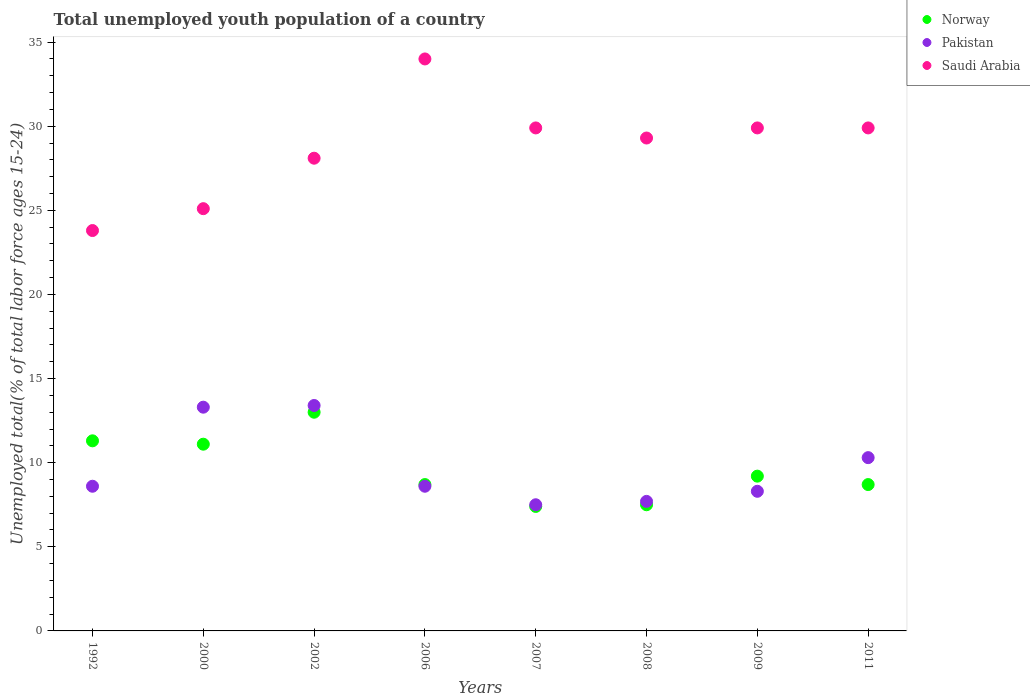How many different coloured dotlines are there?
Your answer should be compact. 3. Is the number of dotlines equal to the number of legend labels?
Your answer should be very brief. Yes. What is the percentage of total unemployed youth population of a country in Pakistan in 2006?
Ensure brevity in your answer.  8.6. Across all years, what is the minimum percentage of total unemployed youth population of a country in Norway?
Offer a terse response. 7.4. In which year was the percentage of total unemployed youth population of a country in Pakistan maximum?
Provide a short and direct response. 2002. In which year was the percentage of total unemployed youth population of a country in Norway minimum?
Your response must be concise. 2007. What is the total percentage of total unemployed youth population of a country in Pakistan in the graph?
Make the answer very short. 77.7. What is the difference between the percentage of total unemployed youth population of a country in Norway in 1992 and that in 2002?
Provide a short and direct response. -1.7. What is the difference between the percentage of total unemployed youth population of a country in Pakistan in 2009 and the percentage of total unemployed youth population of a country in Saudi Arabia in 2008?
Your answer should be compact. -21. What is the average percentage of total unemployed youth population of a country in Saudi Arabia per year?
Give a very brief answer. 28.75. In the year 2007, what is the difference between the percentage of total unemployed youth population of a country in Pakistan and percentage of total unemployed youth population of a country in Norway?
Ensure brevity in your answer.  0.1. What is the ratio of the percentage of total unemployed youth population of a country in Pakistan in 1992 to that in 2000?
Provide a short and direct response. 0.65. What is the difference between the highest and the second highest percentage of total unemployed youth population of a country in Saudi Arabia?
Offer a terse response. 4.1. What is the difference between the highest and the lowest percentage of total unemployed youth population of a country in Norway?
Keep it short and to the point. 5.6. In how many years, is the percentage of total unemployed youth population of a country in Norway greater than the average percentage of total unemployed youth population of a country in Norway taken over all years?
Make the answer very short. 3. Is the sum of the percentage of total unemployed youth population of a country in Norway in 1992 and 2006 greater than the maximum percentage of total unemployed youth population of a country in Saudi Arabia across all years?
Offer a very short reply. No. Is it the case that in every year, the sum of the percentage of total unemployed youth population of a country in Norway and percentage of total unemployed youth population of a country in Pakistan  is greater than the percentage of total unemployed youth population of a country in Saudi Arabia?
Provide a succinct answer. No. Is the percentage of total unemployed youth population of a country in Saudi Arabia strictly greater than the percentage of total unemployed youth population of a country in Pakistan over the years?
Keep it short and to the point. Yes. Is the percentage of total unemployed youth population of a country in Saudi Arabia strictly less than the percentage of total unemployed youth population of a country in Pakistan over the years?
Your response must be concise. No. How many dotlines are there?
Offer a terse response. 3. How many years are there in the graph?
Your response must be concise. 8. Does the graph contain any zero values?
Give a very brief answer. No. How many legend labels are there?
Your answer should be very brief. 3. What is the title of the graph?
Provide a short and direct response. Total unemployed youth population of a country. Does "High income" appear as one of the legend labels in the graph?
Provide a succinct answer. No. What is the label or title of the Y-axis?
Your answer should be compact. Unemployed total(% of total labor force ages 15-24). What is the Unemployed total(% of total labor force ages 15-24) of Norway in 1992?
Offer a very short reply. 11.3. What is the Unemployed total(% of total labor force ages 15-24) of Pakistan in 1992?
Provide a succinct answer. 8.6. What is the Unemployed total(% of total labor force ages 15-24) in Saudi Arabia in 1992?
Provide a succinct answer. 23.8. What is the Unemployed total(% of total labor force ages 15-24) of Norway in 2000?
Your answer should be very brief. 11.1. What is the Unemployed total(% of total labor force ages 15-24) of Pakistan in 2000?
Provide a short and direct response. 13.3. What is the Unemployed total(% of total labor force ages 15-24) of Saudi Arabia in 2000?
Your answer should be very brief. 25.1. What is the Unemployed total(% of total labor force ages 15-24) of Pakistan in 2002?
Your answer should be very brief. 13.4. What is the Unemployed total(% of total labor force ages 15-24) of Saudi Arabia in 2002?
Give a very brief answer. 28.1. What is the Unemployed total(% of total labor force ages 15-24) of Norway in 2006?
Provide a short and direct response. 8.7. What is the Unemployed total(% of total labor force ages 15-24) in Pakistan in 2006?
Your answer should be very brief. 8.6. What is the Unemployed total(% of total labor force ages 15-24) of Norway in 2007?
Provide a succinct answer. 7.4. What is the Unemployed total(% of total labor force ages 15-24) in Saudi Arabia in 2007?
Make the answer very short. 29.9. What is the Unemployed total(% of total labor force ages 15-24) of Pakistan in 2008?
Your answer should be compact. 7.7. What is the Unemployed total(% of total labor force ages 15-24) in Saudi Arabia in 2008?
Your answer should be compact. 29.3. What is the Unemployed total(% of total labor force ages 15-24) of Norway in 2009?
Offer a terse response. 9.2. What is the Unemployed total(% of total labor force ages 15-24) of Pakistan in 2009?
Ensure brevity in your answer.  8.3. What is the Unemployed total(% of total labor force ages 15-24) of Saudi Arabia in 2009?
Give a very brief answer. 29.9. What is the Unemployed total(% of total labor force ages 15-24) of Norway in 2011?
Provide a short and direct response. 8.7. What is the Unemployed total(% of total labor force ages 15-24) in Pakistan in 2011?
Provide a short and direct response. 10.3. What is the Unemployed total(% of total labor force ages 15-24) in Saudi Arabia in 2011?
Keep it short and to the point. 29.9. Across all years, what is the maximum Unemployed total(% of total labor force ages 15-24) of Pakistan?
Your response must be concise. 13.4. Across all years, what is the maximum Unemployed total(% of total labor force ages 15-24) in Saudi Arabia?
Provide a succinct answer. 34. Across all years, what is the minimum Unemployed total(% of total labor force ages 15-24) of Norway?
Your answer should be compact. 7.4. Across all years, what is the minimum Unemployed total(% of total labor force ages 15-24) of Pakistan?
Your answer should be very brief. 7.5. Across all years, what is the minimum Unemployed total(% of total labor force ages 15-24) of Saudi Arabia?
Provide a succinct answer. 23.8. What is the total Unemployed total(% of total labor force ages 15-24) of Norway in the graph?
Keep it short and to the point. 76.9. What is the total Unemployed total(% of total labor force ages 15-24) of Pakistan in the graph?
Offer a very short reply. 77.7. What is the total Unemployed total(% of total labor force ages 15-24) in Saudi Arabia in the graph?
Provide a succinct answer. 230. What is the difference between the Unemployed total(% of total labor force ages 15-24) in Pakistan in 1992 and that in 2002?
Your answer should be compact. -4.8. What is the difference between the Unemployed total(% of total labor force ages 15-24) in Saudi Arabia in 1992 and that in 2002?
Offer a very short reply. -4.3. What is the difference between the Unemployed total(% of total labor force ages 15-24) of Norway in 1992 and that in 2006?
Keep it short and to the point. 2.6. What is the difference between the Unemployed total(% of total labor force ages 15-24) of Saudi Arabia in 1992 and that in 2006?
Provide a short and direct response. -10.2. What is the difference between the Unemployed total(% of total labor force ages 15-24) of Norway in 1992 and that in 2008?
Make the answer very short. 3.8. What is the difference between the Unemployed total(% of total labor force ages 15-24) in Pakistan in 1992 and that in 2008?
Offer a very short reply. 0.9. What is the difference between the Unemployed total(% of total labor force ages 15-24) of Pakistan in 1992 and that in 2009?
Offer a terse response. 0.3. What is the difference between the Unemployed total(% of total labor force ages 15-24) in Saudi Arabia in 1992 and that in 2009?
Provide a short and direct response. -6.1. What is the difference between the Unemployed total(% of total labor force ages 15-24) of Saudi Arabia in 1992 and that in 2011?
Give a very brief answer. -6.1. What is the difference between the Unemployed total(% of total labor force ages 15-24) of Pakistan in 2000 and that in 2002?
Provide a succinct answer. -0.1. What is the difference between the Unemployed total(% of total labor force ages 15-24) of Pakistan in 2000 and that in 2006?
Ensure brevity in your answer.  4.7. What is the difference between the Unemployed total(% of total labor force ages 15-24) in Saudi Arabia in 2000 and that in 2006?
Offer a terse response. -8.9. What is the difference between the Unemployed total(% of total labor force ages 15-24) in Pakistan in 2000 and that in 2007?
Keep it short and to the point. 5.8. What is the difference between the Unemployed total(% of total labor force ages 15-24) in Norway in 2000 and that in 2008?
Ensure brevity in your answer.  3.6. What is the difference between the Unemployed total(% of total labor force ages 15-24) in Saudi Arabia in 2000 and that in 2008?
Your answer should be very brief. -4.2. What is the difference between the Unemployed total(% of total labor force ages 15-24) in Norway in 2000 and that in 2009?
Offer a terse response. 1.9. What is the difference between the Unemployed total(% of total labor force ages 15-24) in Pakistan in 2000 and that in 2009?
Your answer should be very brief. 5. What is the difference between the Unemployed total(% of total labor force ages 15-24) in Saudi Arabia in 2000 and that in 2009?
Make the answer very short. -4.8. What is the difference between the Unemployed total(% of total labor force ages 15-24) in Norway in 2000 and that in 2011?
Keep it short and to the point. 2.4. What is the difference between the Unemployed total(% of total labor force ages 15-24) of Norway in 2002 and that in 2007?
Your answer should be compact. 5.6. What is the difference between the Unemployed total(% of total labor force ages 15-24) in Norway in 2002 and that in 2011?
Provide a succinct answer. 4.3. What is the difference between the Unemployed total(% of total labor force ages 15-24) in Saudi Arabia in 2002 and that in 2011?
Give a very brief answer. -1.8. What is the difference between the Unemployed total(% of total labor force ages 15-24) in Norway in 2006 and that in 2007?
Make the answer very short. 1.3. What is the difference between the Unemployed total(% of total labor force ages 15-24) of Norway in 2006 and that in 2008?
Make the answer very short. 1.2. What is the difference between the Unemployed total(% of total labor force ages 15-24) of Saudi Arabia in 2006 and that in 2008?
Ensure brevity in your answer.  4.7. What is the difference between the Unemployed total(% of total labor force ages 15-24) of Norway in 2006 and that in 2009?
Offer a very short reply. -0.5. What is the difference between the Unemployed total(% of total labor force ages 15-24) of Pakistan in 2006 and that in 2009?
Offer a terse response. 0.3. What is the difference between the Unemployed total(% of total labor force ages 15-24) of Saudi Arabia in 2006 and that in 2009?
Offer a very short reply. 4.1. What is the difference between the Unemployed total(% of total labor force ages 15-24) of Norway in 2006 and that in 2011?
Your answer should be compact. 0. What is the difference between the Unemployed total(% of total labor force ages 15-24) of Saudi Arabia in 2006 and that in 2011?
Your answer should be compact. 4.1. What is the difference between the Unemployed total(% of total labor force ages 15-24) of Pakistan in 2007 and that in 2008?
Your answer should be very brief. -0.2. What is the difference between the Unemployed total(% of total labor force ages 15-24) in Saudi Arabia in 2007 and that in 2009?
Offer a very short reply. 0. What is the difference between the Unemployed total(% of total labor force ages 15-24) of Saudi Arabia in 2007 and that in 2011?
Ensure brevity in your answer.  0. What is the difference between the Unemployed total(% of total labor force ages 15-24) in Saudi Arabia in 2008 and that in 2009?
Offer a very short reply. -0.6. What is the difference between the Unemployed total(% of total labor force ages 15-24) of Saudi Arabia in 2008 and that in 2011?
Offer a terse response. -0.6. What is the difference between the Unemployed total(% of total labor force ages 15-24) of Pakistan in 1992 and the Unemployed total(% of total labor force ages 15-24) of Saudi Arabia in 2000?
Provide a succinct answer. -16.5. What is the difference between the Unemployed total(% of total labor force ages 15-24) of Norway in 1992 and the Unemployed total(% of total labor force ages 15-24) of Saudi Arabia in 2002?
Keep it short and to the point. -16.8. What is the difference between the Unemployed total(% of total labor force ages 15-24) of Pakistan in 1992 and the Unemployed total(% of total labor force ages 15-24) of Saudi Arabia in 2002?
Your answer should be compact. -19.5. What is the difference between the Unemployed total(% of total labor force ages 15-24) of Norway in 1992 and the Unemployed total(% of total labor force ages 15-24) of Saudi Arabia in 2006?
Give a very brief answer. -22.7. What is the difference between the Unemployed total(% of total labor force ages 15-24) of Pakistan in 1992 and the Unemployed total(% of total labor force ages 15-24) of Saudi Arabia in 2006?
Your response must be concise. -25.4. What is the difference between the Unemployed total(% of total labor force ages 15-24) in Norway in 1992 and the Unemployed total(% of total labor force ages 15-24) in Pakistan in 2007?
Your answer should be compact. 3.8. What is the difference between the Unemployed total(% of total labor force ages 15-24) of Norway in 1992 and the Unemployed total(% of total labor force ages 15-24) of Saudi Arabia in 2007?
Provide a short and direct response. -18.6. What is the difference between the Unemployed total(% of total labor force ages 15-24) in Pakistan in 1992 and the Unemployed total(% of total labor force ages 15-24) in Saudi Arabia in 2007?
Your response must be concise. -21.3. What is the difference between the Unemployed total(% of total labor force ages 15-24) of Pakistan in 1992 and the Unemployed total(% of total labor force ages 15-24) of Saudi Arabia in 2008?
Your answer should be compact. -20.7. What is the difference between the Unemployed total(% of total labor force ages 15-24) of Norway in 1992 and the Unemployed total(% of total labor force ages 15-24) of Pakistan in 2009?
Your response must be concise. 3. What is the difference between the Unemployed total(% of total labor force ages 15-24) in Norway in 1992 and the Unemployed total(% of total labor force ages 15-24) in Saudi Arabia in 2009?
Provide a succinct answer. -18.6. What is the difference between the Unemployed total(% of total labor force ages 15-24) of Pakistan in 1992 and the Unemployed total(% of total labor force ages 15-24) of Saudi Arabia in 2009?
Your response must be concise. -21.3. What is the difference between the Unemployed total(% of total labor force ages 15-24) of Norway in 1992 and the Unemployed total(% of total labor force ages 15-24) of Pakistan in 2011?
Your response must be concise. 1. What is the difference between the Unemployed total(% of total labor force ages 15-24) of Norway in 1992 and the Unemployed total(% of total labor force ages 15-24) of Saudi Arabia in 2011?
Give a very brief answer. -18.6. What is the difference between the Unemployed total(% of total labor force ages 15-24) in Pakistan in 1992 and the Unemployed total(% of total labor force ages 15-24) in Saudi Arabia in 2011?
Offer a very short reply. -21.3. What is the difference between the Unemployed total(% of total labor force ages 15-24) in Norway in 2000 and the Unemployed total(% of total labor force ages 15-24) in Saudi Arabia in 2002?
Offer a terse response. -17. What is the difference between the Unemployed total(% of total labor force ages 15-24) of Pakistan in 2000 and the Unemployed total(% of total labor force ages 15-24) of Saudi Arabia in 2002?
Provide a succinct answer. -14.8. What is the difference between the Unemployed total(% of total labor force ages 15-24) in Norway in 2000 and the Unemployed total(% of total labor force ages 15-24) in Saudi Arabia in 2006?
Give a very brief answer. -22.9. What is the difference between the Unemployed total(% of total labor force ages 15-24) of Pakistan in 2000 and the Unemployed total(% of total labor force ages 15-24) of Saudi Arabia in 2006?
Ensure brevity in your answer.  -20.7. What is the difference between the Unemployed total(% of total labor force ages 15-24) in Norway in 2000 and the Unemployed total(% of total labor force ages 15-24) in Saudi Arabia in 2007?
Ensure brevity in your answer.  -18.8. What is the difference between the Unemployed total(% of total labor force ages 15-24) in Pakistan in 2000 and the Unemployed total(% of total labor force ages 15-24) in Saudi Arabia in 2007?
Offer a very short reply. -16.6. What is the difference between the Unemployed total(% of total labor force ages 15-24) in Norway in 2000 and the Unemployed total(% of total labor force ages 15-24) in Saudi Arabia in 2008?
Give a very brief answer. -18.2. What is the difference between the Unemployed total(% of total labor force ages 15-24) of Pakistan in 2000 and the Unemployed total(% of total labor force ages 15-24) of Saudi Arabia in 2008?
Ensure brevity in your answer.  -16. What is the difference between the Unemployed total(% of total labor force ages 15-24) of Norway in 2000 and the Unemployed total(% of total labor force ages 15-24) of Pakistan in 2009?
Make the answer very short. 2.8. What is the difference between the Unemployed total(% of total labor force ages 15-24) of Norway in 2000 and the Unemployed total(% of total labor force ages 15-24) of Saudi Arabia in 2009?
Ensure brevity in your answer.  -18.8. What is the difference between the Unemployed total(% of total labor force ages 15-24) in Pakistan in 2000 and the Unemployed total(% of total labor force ages 15-24) in Saudi Arabia in 2009?
Provide a short and direct response. -16.6. What is the difference between the Unemployed total(% of total labor force ages 15-24) of Norway in 2000 and the Unemployed total(% of total labor force ages 15-24) of Saudi Arabia in 2011?
Offer a terse response. -18.8. What is the difference between the Unemployed total(% of total labor force ages 15-24) of Pakistan in 2000 and the Unemployed total(% of total labor force ages 15-24) of Saudi Arabia in 2011?
Make the answer very short. -16.6. What is the difference between the Unemployed total(% of total labor force ages 15-24) of Norway in 2002 and the Unemployed total(% of total labor force ages 15-24) of Pakistan in 2006?
Offer a very short reply. 4.4. What is the difference between the Unemployed total(% of total labor force ages 15-24) in Pakistan in 2002 and the Unemployed total(% of total labor force ages 15-24) in Saudi Arabia in 2006?
Your response must be concise. -20.6. What is the difference between the Unemployed total(% of total labor force ages 15-24) in Norway in 2002 and the Unemployed total(% of total labor force ages 15-24) in Saudi Arabia in 2007?
Your response must be concise. -16.9. What is the difference between the Unemployed total(% of total labor force ages 15-24) of Pakistan in 2002 and the Unemployed total(% of total labor force ages 15-24) of Saudi Arabia in 2007?
Provide a short and direct response. -16.5. What is the difference between the Unemployed total(% of total labor force ages 15-24) in Norway in 2002 and the Unemployed total(% of total labor force ages 15-24) in Pakistan in 2008?
Offer a very short reply. 5.3. What is the difference between the Unemployed total(% of total labor force ages 15-24) of Norway in 2002 and the Unemployed total(% of total labor force ages 15-24) of Saudi Arabia in 2008?
Give a very brief answer. -16.3. What is the difference between the Unemployed total(% of total labor force ages 15-24) in Pakistan in 2002 and the Unemployed total(% of total labor force ages 15-24) in Saudi Arabia in 2008?
Provide a succinct answer. -15.9. What is the difference between the Unemployed total(% of total labor force ages 15-24) in Norway in 2002 and the Unemployed total(% of total labor force ages 15-24) in Saudi Arabia in 2009?
Keep it short and to the point. -16.9. What is the difference between the Unemployed total(% of total labor force ages 15-24) of Pakistan in 2002 and the Unemployed total(% of total labor force ages 15-24) of Saudi Arabia in 2009?
Make the answer very short. -16.5. What is the difference between the Unemployed total(% of total labor force ages 15-24) in Norway in 2002 and the Unemployed total(% of total labor force ages 15-24) in Pakistan in 2011?
Your response must be concise. 2.7. What is the difference between the Unemployed total(% of total labor force ages 15-24) in Norway in 2002 and the Unemployed total(% of total labor force ages 15-24) in Saudi Arabia in 2011?
Your response must be concise. -16.9. What is the difference between the Unemployed total(% of total labor force ages 15-24) of Pakistan in 2002 and the Unemployed total(% of total labor force ages 15-24) of Saudi Arabia in 2011?
Your answer should be compact. -16.5. What is the difference between the Unemployed total(% of total labor force ages 15-24) in Norway in 2006 and the Unemployed total(% of total labor force ages 15-24) in Pakistan in 2007?
Offer a terse response. 1.2. What is the difference between the Unemployed total(% of total labor force ages 15-24) of Norway in 2006 and the Unemployed total(% of total labor force ages 15-24) of Saudi Arabia in 2007?
Your answer should be very brief. -21.2. What is the difference between the Unemployed total(% of total labor force ages 15-24) in Pakistan in 2006 and the Unemployed total(% of total labor force ages 15-24) in Saudi Arabia in 2007?
Offer a very short reply. -21.3. What is the difference between the Unemployed total(% of total labor force ages 15-24) of Norway in 2006 and the Unemployed total(% of total labor force ages 15-24) of Pakistan in 2008?
Give a very brief answer. 1. What is the difference between the Unemployed total(% of total labor force ages 15-24) in Norway in 2006 and the Unemployed total(% of total labor force ages 15-24) in Saudi Arabia in 2008?
Offer a terse response. -20.6. What is the difference between the Unemployed total(% of total labor force ages 15-24) of Pakistan in 2006 and the Unemployed total(% of total labor force ages 15-24) of Saudi Arabia in 2008?
Your answer should be very brief. -20.7. What is the difference between the Unemployed total(% of total labor force ages 15-24) in Norway in 2006 and the Unemployed total(% of total labor force ages 15-24) in Saudi Arabia in 2009?
Make the answer very short. -21.2. What is the difference between the Unemployed total(% of total labor force ages 15-24) in Pakistan in 2006 and the Unemployed total(% of total labor force ages 15-24) in Saudi Arabia in 2009?
Offer a very short reply. -21.3. What is the difference between the Unemployed total(% of total labor force ages 15-24) in Norway in 2006 and the Unemployed total(% of total labor force ages 15-24) in Pakistan in 2011?
Offer a very short reply. -1.6. What is the difference between the Unemployed total(% of total labor force ages 15-24) in Norway in 2006 and the Unemployed total(% of total labor force ages 15-24) in Saudi Arabia in 2011?
Keep it short and to the point. -21.2. What is the difference between the Unemployed total(% of total labor force ages 15-24) of Pakistan in 2006 and the Unemployed total(% of total labor force ages 15-24) of Saudi Arabia in 2011?
Make the answer very short. -21.3. What is the difference between the Unemployed total(% of total labor force ages 15-24) in Norway in 2007 and the Unemployed total(% of total labor force ages 15-24) in Pakistan in 2008?
Offer a very short reply. -0.3. What is the difference between the Unemployed total(% of total labor force ages 15-24) in Norway in 2007 and the Unemployed total(% of total labor force ages 15-24) in Saudi Arabia in 2008?
Ensure brevity in your answer.  -21.9. What is the difference between the Unemployed total(% of total labor force ages 15-24) of Pakistan in 2007 and the Unemployed total(% of total labor force ages 15-24) of Saudi Arabia in 2008?
Provide a short and direct response. -21.8. What is the difference between the Unemployed total(% of total labor force ages 15-24) in Norway in 2007 and the Unemployed total(% of total labor force ages 15-24) in Pakistan in 2009?
Your response must be concise. -0.9. What is the difference between the Unemployed total(% of total labor force ages 15-24) of Norway in 2007 and the Unemployed total(% of total labor force ages 15-24) of Saudi Arabia in 2009?
Provide a succinct answer. -22.5. What is the difference between the Unemployed total(% of total labor force ages 15-24) of Pakistan in 2007 and the Unemployed total(% of total labor force ages 15-24) of Saudi Arabia in 2009?
Your response must be concise. -22.4. What is the difference between the Unemployed total(% of total labor force ages 15-24) of Norway in 2007 and the Unemployed total(% of total labor force ages 15-24) of Pakistan in 2011?
Your response must be concise. -2.9. What is the difference between the Unemployed total(% of total labor force ages 15-24) in Norway in 2007 and the Unemployed total(% of total labor force ages 15-24) in Saudi Arabia in 2011?
Your response must be concise. -22.5. What is the difference between the Unemployed total(% of total labor force ages 15-24) in Pakistan in 2007 and the Unemployed total(% of total labor force ages 15-24) in Saudi Arabia in 2011?
Make the answer very short. -22.4. What is the difference between the Unemployed total(% of total labor force ages 15-24) of Norway in 2008 and the Unemployed total(% of total labor force ages 15-24) of Pakistan in 2009?
Provide a succinct answer. -0.8. What is the difference between the Unemployed total(% of total labor force ages 15-24) of Norway in 2008 and the Unemployed total(% of total labor force ages 15-24) of Saudi Arabia in 2009?
Keep it short and to the point. -22.4. What is the difference between the Unemployed total(% of total labor force ages 15-24) in Pakistan in 2008 and the Unemployed total(% of total labor force ages 15-24) in Saudi Arabia in 2009?
Give a very brief answer. -22.2. What is the difference between the Unemployed total(% of total labor force ages 15-24) in Norway in 2008 and the Unemployed total(% of total labor force ages 15-24) in Pakistan in 2011?
Keep it short and to the point. -2.8. What is the difference between the Unemployed total(% of total labor force ages 15-24) in Norway in 2008 and the Unemployed total(% of total labor force ages 15-24) in Saudi Arabia in 2011?
Your answer should be compact. -22.4. What is the difference between the Unemployed total(% of total labor force ages 15-24) of Pakistan in 2008 and the Unemployed total(% of total labor force ages 15-24) of Saudi Arabia in 2011?
Your answer should be compact. -22.2. What is the difference between the Unemployed total(% of total labor force ages 15-24) in Norway in 2009 and the Unemployed total(% of total labor force ages 15-24) in Saudi Arabia in 2011?
Make the answer very short. -20.7. What is the difference between the Unemployed total(% of total labor force ages 15-24) in Pakistan in 2009 and the Unemployed total(% of total labor force ages 15-24) in Saudi Arabia in 2011?
Provide a short and direct response. -21.6. What is the average Unemployed total(% of total labor force ages 15-24) of Norway per year?
Make the answer very short. 9.61. What is the average Unemployed total(% of total labor force ages 15-24) of Pakistan per year?
Make the answer very short. 9.71. What is the average Unemployed total(% of total labor force ages 15-24) in Saudi Arabia per year?
Provide a succinct answer. 28.75. In the year 1992, what is the difference between the Unemployed total(% of total labor force ages 15-24) of Norway and Unemployed total(% of total labor force ages 15-24) of Pakistan?
Your answer should be compact. 2.7. In the year 1992, what is the difference between the Unemployed total(% of total labor force ages 15-24) in Pakistan and Unemployed total(% of total labor force ages 15-24) in Saudi Arabia?
Make the answer very short. -15.2. In the year 2002, what is the difference between the Unemployed total(% of total labor force ages 15-24) in Norway and Unemployed total(% of total labor force ages 15-24) in Pakistan?
Make the answer very short. -0.4. In the year 2002, what is the difference between the Unemployed total(% of total labor force ages 15-24) of Norway and Unemployed total(% of total labor force ages 15-24) of Saudi Arabia?
Your answer should be very brief. -15.1. In the year 2002, what is the difference between the Unemployed total(% of total labor force ages 15-24) in Pakistan and Unemployed total(% of total labor force ages 15-24) in Saudi Arabia?
Give a very brief answer. -14.7. In the year 2006, what is the difference between the Unemployed total(% of total labor force ages 15-24) of Norway and Unemployed total(% of total labor force ages 15-24) of Pakistan?
Give a very brief answer. 0.1. In the year 2006, what is the difference between the Unemployed total(% of total labor force ages 15-24) of Norway and Unemployed total(% of total labor force ages 15-24) of Saudi Arabia?
Offer a very short reply. -25.3. In the year 2006, what is the difference between the Unemployed total(% of total labor force ages 15-24) in Pakistan and Unemployed total(% of total labor force ages 15-24) in Saudi Arabia?
Ensure brevity in your answer.  -25.4. In the year 2007, what is the difference between the Unemployed total(% of total labor force ages 15-24) in Norway and Unemployed total(% of total labor force ages 15-24) in Saudi Arabia?
Provide a succinct answer. -22.5. In the year 2007, what is the difference between the Unemployed total(% of total labor force ages 15-24) in Pakistan and Unemployed total(% of total labor force ages 15-24) in Saudi Arabia?
Your answer should be compact. -22.4. In the year 2008, what is the difference between the Unemployed total(% of total labor force ages 15-24) of Norway and Unemployed total(% of total labor force ages 15-24) of Pakistan?
Ensure brevity in your answer.  -0.2. In the year 2008, what is the difference between the Unemployed total(% of total labor force ages 15-24) in Norway and Unemployed total(% of total labor force ages 15-24) in Saudi Arabia?
Keep it short and to the point. -21.8. In the year 2008, what is the difference between the Unemployed total(% of total labor force ages 15-24) in Pakistan and Unemployed total(% of total labor force ages 15-24) in Saudi Arabia?
Your answer should be compact. -21.6. In the year 2009, what is the difference between the Unemployed total(% of total labor force ages 15-24) in Norway and Unemployed total(% of total labor force ages 15-24) in Saudi Arabia?
Your response must be concise. -20.7. In the year 2009, what is the difference between the Unemployed total(% of total labor force ages 15-24) of Pakistan and Unemployed total(% of total labor force ages 15-24) of Saudi Arabia?
Offer a very short reply. -21.6. In the year 2011, what is the difference between the Unemployed total(% of total labor force ages 15-24) of Norway and Unemployed total(% of total labor force ages 15-24) of Saudi Arabia?
Make the answer very short. -21.2. In the year 2011, what is the difference between the Unemployed total(% of total labor force ages 15-24) of Pakistan and Unemployed total(% of total labor force ages 15-24) of Saudi Arabia?
Provide a succinct answer. -19.6. What is the ratio of the Unemployed total(% of total labor force ages 15-24) of Norway in 1992 to that in 2000?
Provide a short and direct response. 1.02. What is the ratio of the Unemployed total(% of total labor force ages 15-24) in Pakistan in 1992 to that in 2000?
Keep it short and to the point. 0.65. What is the ratio of the Unemployed total(% of total labor force ages 15-24) of Saudi Arabia in 1992 to that in 2000?
Give a very brief answer. 0.95. What is the ratio of the Unemployed total(% of total labor force ages 15-24) in Norway in 1992 to that in 2002?
Keep it short and to the point. 0.87. What is the ratio of the Unemployed total(% of total labor force ages 15-24) in Pakistan in 1992 to that in 2002?
Offer a terse response. 0.64. What is the ratio of the Unemployed total(% of total labor force ages 15-24) of Saudi Arabia in 1992 to that in 2002?
Your response must be concise. 0.85. What is the ratio of the Unemployed total(% of total labor force ages 15-24) in Norway in 1992 to that in 2006?
Offer a terse response. 1.3. What is the ratio of the Unemployed total(% of total labor force ages 15-24) in Norway in 1992 to that in 2007?
Your response must be concise. 1.53. What is the ratio of the Unemployed total(% of total labor force ages 15-24) in Pakistan in 1992 to that in 2007?
Your answer should be very brief. 1.15. What is the ratio of the Unemployed total(% of total labor force ages 15-24) of Saudi Arabia in 1992 to that in 2007?
Your response must be concise. 0.8. What is the ratio of the Unemployed total(% of total labor force ages 15-24) of Norway in 1992 to that in 2008?
Your response must be concise. 1.51. What is the ratio of the Unemployed total(% of total labor force ages 15-24) in Pakistan in 1992 to that in 2008?
Keep it short and to the point. 1.12. What is the ratio of the Unemployed total(% of total labor force ages 15-24) of Saudi Arabia in 1992 to that in 2008?
Your answer should be compact. 0.81. What is the ratio of the Unemployed total(% of total labor force ages 15-24) in Norway in 1992 to that in 2009?
Make the answer very short. 1.23. What is the ratio of the Unemployed total(% of total labor force ages 15-24) in Pakistan in 1992 to that in 2009?
Offer a terse response. 1.04. What is the ratio of the Unemployed total(% of total labor force ages 15-24) in Saudi Arabia in 1992 to that in 2009?
Offer a very short reply. 0.8. What is the ratio of the Unemployed total(% of total labor force ages 15-24) in Norway in 1992 to that in 2011?
Your response must be concise. 1.3. What is the ratio of the Unemployed total(% of total labor force ages 15-24) of Pakistan in 1992 to that in 2011?
Keep it short and to the point. 0.83. What is the ratio of the Unemployed total(% of total labor force ages 15-24) in Saudi Arabia in 1992 to that in 2011?
Provide a short and direct response. 0.8. What is the ratio of the Unemployed total(% of total labor force ages 15-24) in Norway in 2000 to that in 2002?
Ensure brevity in your answer.  0.85. What is the ratio of the Unemployed total(% of total labor force ages 15-24) of Pakistan in 2000 to that in 2002?
Your answer should be compact. 0.99. What is the ratio of the Unemployed total(% of total labor force ages 15-24) in Saudi Arabia in 2000 to that in 2002?
Your response must be concise. 0.89. What is the ratio of the Unemployed total(% of total labor force ages 15-24) in Norway in 2000 to that in 2006?
Give a very brief answer. 1.28. What is the ratio of the Unemployed total(% of total labor force ages 15-24) in Pakistan in 2000 to that in 2006?
Provide a short and direct response. 1.55. What is the ratio of the Unemployed total(% of total labor force ages 15-24) of Saudi Arabia in 2000 to that in 2006?
Provide a short and direct response. 0.74. What is the ratio of the Unemployed total(% of total labor force ages 15-24) of Pakistan in 2000 to that in 2007?
Make the answer very short. 1.77. What is the ratio of the Unemployed total(% of total labor force ages 15-24) in Saudi Arabia in 2000 to that in 2007?
Offer a very short reply. 0.84. What is the ratio of the Unemployed total(% of total labor force ages 15-24) in Norway in 2000 to that in 2008?
Keep it short and to the point. 1.48. What is the ratio of the Unemployed total(% of total labor force ages 15-24) of Pakistan in 2000 to that in 2008?
Keep it short and to the point. 1.73. What is the ratio of the Unemployed total(% of total labor force ages 15-24) of Saudi Arabia in 2000 to that in 2008?
Provide a short and direct response. 0.86. What is the ratio of the Unemployed total(% of total labor force ages 15-24) of Norway in 2000 to that in 2009?
Keep it short and to the point. 1.21. What is the ratio of the Unemployed total(% of total labor force ages 15-24) in Pakistan in 2000 to that in 2009?
Ensure brevity in your answer.  1.6. What is the ratio of the Unemployed total(% of total labor force ages 15-24) of Saudi Arabia in 2000 to that in 2009?
Offer a very short reply. 0.84. What is the ratio of the Unemployed total(% of total labor force ages 15-24) in Norway in 2000 to that in 2011?
Offer a very short reply. 1.28. What is the ratio of the Unemployed total(% of total labor force ages 15-24) in Pakistan in 2000 to that in 2011?
Your answer should be very brief. 1.29. What is the ratio of the Unemployed total(% of total labor force ages 15-24) of Saudi Arabia in 2000 to that in 2011?
Ensure brevity in your answer.  0.84. What is the ratio of the Unemployed total(% of total labor force ages 15-24) of Norway in 2002 to that in 2006?
Offer a very short reply. 1.49. What is the ratio of the Unemployed total(% of total labor force ages 15-24) in Pakistan in 2002 to that in 2006?
Give a very brief answer. 1.56. What is the ratio of the Unemployed total(% of total labor force ages 15-24) of Saudi Arabia in 2002 to that in 2006?
Keep it short and to the point. 0.83. What is the ratio of the Unemployed total(% of total labor force ages 15-24) of Norway in 2002 to that in 2007?
Offer a very short reply. 1.76. What is the ratio of the Unemployed total(% of total labor force ages 15-24) in Pakistan in 2002 to that in 2007?
Your answer should be compact. 1.79. What is the ratio of the Unemployed total(% of total labor force ages 15-24) in Saudi Arabia in 2002 to that in 2007?
Keep it short and to the point. 0.94. What is the ratio of the Unemployed total(% of total labor force ages 15-24) of Norway in 2002 to that in 2008?
Offer a terse response. 1.73. What is the ratio of the Unemployed total(% of total labor force ages 15-24) in Pakistan in 2002 to that in 2008?
Offer a very short reply. 1.74. What is the ratio of the Unemployed total(% of total labor force ages 15-24) in Saudi Arabia in 2002 to that in 2008?
Make the answer very short. 0.96. What is the ratio of the Unemployed total(% of total labor force ages 15-24) in Norway in 2002 to that in 2009?
Keep it short and to the point. 1.41. What is the ratio of the Unemployed total(% of total labor force ages 15-24) of Pakistan in 2002 to that in 2009?
Your answer should be compact. 1.61. What is the ratio of the Unemployed total(% of total labor force ages 15-24) of Saudi Arabia in 2002 to that in 2009?
Keep it short and to the point. 0.94. What is the ratio of the Unemployed total(% of total labor force ages 15-24) in Norway in 2002 to that in 2011?
Your answer should be compact. 1.49. What is the ratio of the Unemployed total(% of total labor force ages 15-24) of Pakistan in 2002 to that in 2011?
Keep it short and to the point. 1.3. What is the ratio of the Unemployed total(% of total labor force ages 15-24) in Saudi Arabia in 2002 to that in 2011?
Ensure brevity in your answer.  0.94. What is the ratio of the Unemployed total(% of total labor force ages 15-24) in Norway in 2006 to that in 2007?
Offer a very short reply. 1.18. What is the ratio of the Unemployed total(% of total labor force ages 15-24) of Pakistan in 2006 to that in 2007?
Provide a succinct answer. 1.15. What is the ratio of the Unemployed total(% of total labor force ages 15-24) in Saudi Arabia in 2006 to that in 2007?
Ensure brevity in your answer.  1.14. What is the ratio of the Unemployed total(% of total labor force ages 15-24) of Norway in 2006 to that in 2008?
Give a very brief answer. 1.16. What is the ratio of the Unemployed total(% of total labor force ages 15-24) of Pakistan in 2006 to that in 2008?
Keep it short and to the point. 1.12. What is the ratio of the Unemployed total(% of total labor force ages 15-24) in Saudi Arabia in 2006 to that in 2008?
Your answer should be compact. 1.16. What is the ratio of the Unemployed total(% of total labor force ages 15-24) of Norway in 2006 to that in 2009?
Make the answer very short. 0.95. What is the ratio of the Unemployed total(% of total labor force ages 15-24) in Pakistan in 2006 to that in 2009?
Provide a short and direct response. 1.04. What is the ratio of the Unemployed total(% of total labor force ages 15-24) of Saudi Arabia in 2006 to that in 2009?
Give a very brief answer. 1.14. What is the ratio of the Unemployed total(% of total labor force ages 15-24) of Norway in 2006 to that in 2011?
Provide a succinct answer. 1. What is the ratio of the Unemployed total(% of total labor force ages 15-24) of Pakistan in 2006 to that in 2011?
Offer a terse response. 0.83. What is the ratio of the Unemployed total(% of total labor force ages 15-24) of Saudi Arabia in 2006 to that in 2011?
Give a very brief answer. 1.14. What is the ratio of the Unemployed total(% of total labor force ages 15-24) of Norway in 2007 to that in 2008?
Offer a very short reply. 0.99. What is the ratio of the Unemployed total(% of total labor force ages 15-24) in Pakistan in 2007 to that in 2008?
Your response must be concise. 0.97. What is the ratio of the Unemployed total(% of total labor force ages 15-24) in Saudi Arabia in 2007 to that in 2008?
Offer a very short reply. 1.02. What is the ratio of the Unemployed total(% of total labor force ages 15-24) in Norway in 2007 to that in 2009?
Your response must be concise. 0.8. What is the ratio of the Unemployed total(% of total labor force ages 15-24) in Pakistan in 2007 to that in 2009?
Provide a succinct answer. 0.9. What is the ratio of the Unemployed total(% of total labor force ages 15-24) in Norway in 2007 to that in 2011?
Your answer should be very brief. 0.85. What is the ratio of the Unemployed total(% of total labor force ages 15-24) of Pakistan in 2007 to that in 2011?
Provide a succinct answer. 0.73. What is the ratio of the Unemployed total(% of total labor force ages 15-24) of Saudi Arabia in 2007 to that in 2011?
Provide a short and direct response. 1. What is the ratio of the Unemployed total(% of total labor force ages 15-24) of Norway in 2008 to that in 2009?
Your answer should be very brief. 0.82. What is the ratio of the Unemployed total(% of total labor force ages 15-24) of Pakistan in 2008 to that in 2009?
Your answer should be compact. 0.93. What is the ratio of the Unemployed total(% of total labor force ages 15-24) of Saudi Arabia in 2008 to that in 2009?
Ensure brevity in your answer.  0.98. What is the ratio of the Unemployed total(% of total labor force ages 15-24) of Norway in 2008 to that in 2011?
Your answer should be compact. 0.86. What is the ratio of the Unemployed total(% of total labor force ages 15-24) of Pakistan in 2008 to that in 2011?
Your response must be concise. 0.75. What is the ratio of the Unemployed total(% of total labor force ages 15-24) in Saudi Arabia in 2008 to that in 2011?
Ensure brevity in your answer.  0.98. What is the ratio of the Unemployed total(% of total labor force ages 15-24) in Norway in 2009 to that in 2011?
Your answer should be very brief. 1.06. What is the ratio of the Unemployed total(% of total labor force ages 15-24) of Pakistan in 2009 to that in 2011?
Your response must be concise. 0.81. What is the ratio of the Unemployed total(% of total labor force ages 15-24) of Saudi Arabia in 2009 to that in 2011?
Give a very brief answer. 1. What is the difference between the highest and the second highest Unemployed total(% of total labor force ages 15-24) in Pakistan?
Provide a succinct answer. 0.1. What is the difference between the highest and the lowest Unemployed total(% of total labor force ages 15-24) of Norway?
Provide a succinct answer. 5.6. What is the difference between the highest and the lowest Unemployed total(% of total labor force ages 15-24) in Saudi Arabia?
Provide a short and direct response. 10.2. 